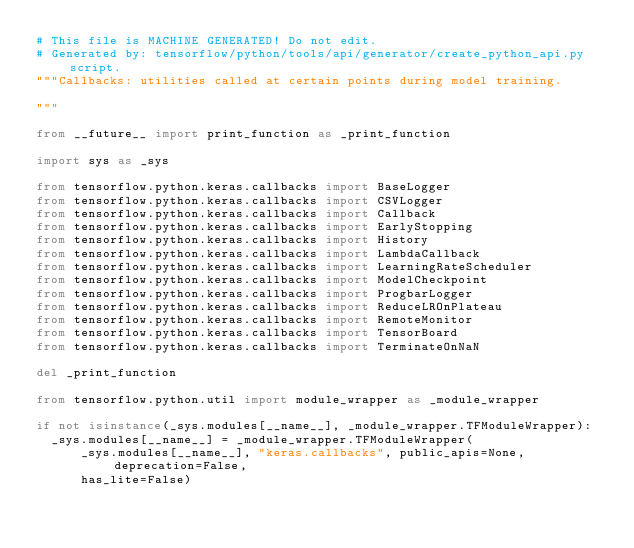Convert code to text. <code><loc_0><loc_0><loc_500><loc_500><_Python_># This file is MACHINE GENERATED! Do not edit.
# Generated by: tensorflow/python/tools/api/generator/create_python_api.py script.
"""Callbacks: utilities called at certain points during model training.

"""

from __future__ import print_function as _print_function

import sys as _sys

from tensorflow.python.keras.callbacks import BaseLogger
from tensorflow.python.keras.callbacks import CSVLogger
from tensorflow.python.keras.callbacks import Callback
from tensorflow.python.keras.callbacks import EarlyStopping
from tensorflow.python.keras.callbacks import History
from tensorflow.python.keras.callbacks import LambdaCallback
from tensorflow.python.keras.callbacks import LearningRateScheduler
from tensorflow.python.keras.callbacks import ModelCheckpoint
from tensorflow.python.keras.callbacks import ProgbarLogger
from tensorflow.python.keras.callbacks import ReduceLROnPlateau
from tensorflow.python.keras.callbacks import RemoteMonitor
from tensorflow.python.keras.callbacks import TensorBoard
from tensorflow.python.keras.callbacks import TerminateOnNaN

del _print_function

from tensorflow.python.util import module_wrapper as _module_wrapper

if not isinstance(_sys.modules[__name__], _module_wrapper.TFModuleWrapper):
  _sys.modules[__name__] = _module_wrapper.TFModuleWrapper(
      _sys.modules[__name__], "keras.callbacks", public_apis=None, deprecation=False,
      has_lite=False)
</code> 